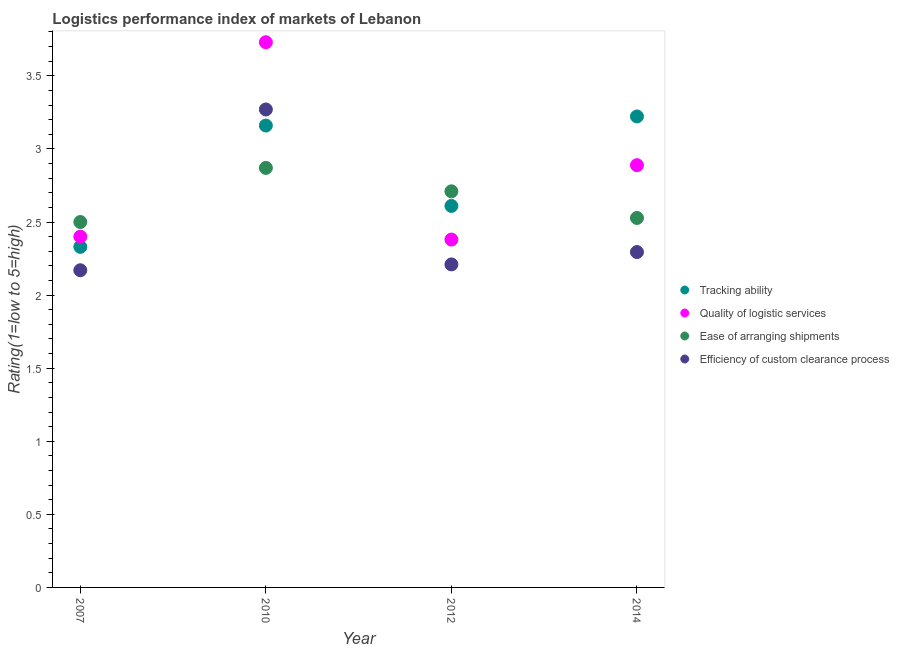Is the number of dotlines equal to the number of legend labels?
Give a very brief answer. Yes. What is the lpi rating of tracking ability in 2012?
Your answer should be very brief. 2.61. Across all years, what is the maximum lpi rating of efficiency of custom clearance process?
Offer a terse response. 3.27. Across all years, what is the minimum lpi rating of quality of logistic services?
Your answer should be very brief. 2.38. In which year was the lpi rating of ease of arranging shipments minimum?
Ensure brevity in your answer.  2007. What is the total lpi rating of tracking ability in the graph?
Your answer should be compact. 11.32. What is the difference between the lpi rating of efficiency of custom clearance process in 2012 and that in 2014?
Keep it short and to the point. -0.08. What is the difference between the lpi rating of efficiency of custom clearance process in 2007 and the lpi rating of tracking ability in 2014?
Ensure brevity in your answer.  -1.05. What is the average lpi rating of tracking ability per year?
Offer a very short reply. 2.83. In the year 2010, what is the difference between the lpi rating of tracking ability and lpi rating of quality of logistic services?
Make the answer very short. -0.57. In how many years, is the lpi rating of efficiency of custom clearance process greater than 2.6?
Ensure brevity in your answer.  1. What is the ratio of the lpi rating of quality of logistic services in 2010 to that in 2014?
Give a very brief answer. 1.29. Is the lpi rating of tracking ability in 2007 less than that in 2010?
Provide a succinct answer. Yes. What is the difference between the highest and the second highest lpi rating of efficiency of custom clearance process?
Offer a terse response. 0.98. What is the difference between the highest and the lowest lpi rating of quality of logistic services?
Your answer should be very brief. 1.35. In how many years, is the lpi rating of tracking ability greater than the average lpi rating of tracking ability taken over all years?
Make the answer very short. 2. Is the sum of the lpi rating of ease of arranging shipments in 2012 and 2014 greater than the maximum lpi rating of tracking ability across all years?
Your answer should be very brief. Yes. Is it the case that in every year, the sum of the lpi rating of tracking ability and lpi rating of quality of logistic services is greater than the lpi rating of ease of arranging shipments?
Your answer should be very brief. Yes. Does the lpi rating of quality of logistic services monotonically increase over the years?
Offer a very short reply. No. Is the lpi rating of tracking ability strictly greater than the lpi rating of quality of logistic services over the years?
Give a very brief answer. No. Is the lpi rating of efficiency of custom clearance process strictly less than the lpi rating of ease of arranging shipments over the years?
Ensure brevity in your answer.  No. How many years are there in the graph?
Provide a succinct answer. 4. What is the difference between two consecutive major ticks on the Y-axis?
Your answer should be very brief. 0.5. Are the values on the major ticks of Y-axis written in scientific E-notation?
Offer a very short reply. No. Does the graph contain any zero values?
Offer a terse response. No. Does the graph contain grids?
Offer a terse response. No. How many legend labels are there?
Your response must be concise. 4. What is the title of the graph?
Provide a short and direct response. Logistics performance index of markets of Lebanon. Does "Source data assessment" appear as one of the legend labels in the graph?
Your answer should be compact. No. What is the label or title of the X-axis?
Offer a very short reply. Year. What is the label or title of the Y-axis?
Keep it short and to the point. Rating(1=low to 5=high). What is the Rating(1=low to 5=high) of Tracking ability in 2007?
Give a very brief answer. 2.33. What is the Rating(1=low to 5=high) in Quality of logistic services in 2007?
Ensure brevity in your answer.  2.4. What is the Rating(1=low to 5=high) of Efficiency of custom clearance process in 2007?
Provide a short and direct response. 2.17. What is the Rating(1=low to 5=high) in Tracking ability in 2010?
Your answer should be very brief. 3.16. What is the Rating(1=low to 5=high) in Quality of logistic services in 2010?
Provide a short and direct response. 3.73. What is the Rating(1=low to 5=high) in Ease of arranging shipments in 2010?
Offer a very short reply. 2.87. What is the Rating(1=low to 5=high) of Efficiency of custom clearance process in 2010?
Give a very brief answer. 3.27. What is the Rating(1=low to 5=high) in Tracking ability in 2012?
Ensure brevity in your answer.  2.61. What is the Rating(1=low to 5=high) of Quality of logistic services in 2012?
Provide a succinct answer. 2.38. What is the Rating(1=low to 5=high) of Ease of arranging shipments in 2012?
Provide a succinct answer. 2.71. What is the Rating(1=low to 5=high) in Efficiency of custom clearance process in 2012?
Your answer should be very brief. 2.21. What is the Rating(1=low to 5=high) of Tracking ability in 2014?
Make the answer very short. 3.22. What is the Rating(1=low to 5=high) of Quality of logistic services in 2014?
Provide a succinct answer. 2.89. What is the Rating(1=low to 5=high) in Ease of arranging shipments in 2014?
Offer a very short reply. 2.53. What is the Rating(1=low to 5=high) in Efficiency of custom clearance process in 2014?
Give a very brief answer. 2.29. Across all years, what is the maximum Rating(1=low to 5=high) in Tracking ability?
Offer a terse response. 3.22. Across all years, what is the maximum Rating(1=low to 5=high) of Quality of logistic services?
Your response must be concise. 3.73. Across all years, what is the maximum Rating(1=low to 5=high) of Ease of arranging shipments?
Your answer should be compact. 2.87. Across all years, what is the maximum Rating(1=low to 5=high) in Efficiency of custom clearance process?
Offer a very short reply. 3.27. Across all years, what is the minimum Rating(1=low to 5=high) of Tracking ability?
Your answer should be compact. 2.33. Across all years, what is the minimum Rating(1=low to 5=high) of Quality of logistic services?
Give a very brief answer. 2.38. Across all years, what is the minimum Rating(1=low to 5=high) of Efficiency of custom clearance process?
Give a very brief answer. 2.17. What is the total Rating(1=low to 5=high) in Tracking ability in the graph?
Make the answer very short. 11.32. What is the total Rating(1=low to 5=high) in Quality of logistic services in the graph?
Offer a very short reply. 11.4. What is the total Rating(1=low to 5=high) of Ease of arranging shipments in the graph?
Your response must be concise. 10.61. What is the total Rating(1=low to 5=high) in Efficiency of custom clearance process in the graph?
Give a very brief answer. 9.94. What is the difference between the Rating(1=low to 5=high) of Tracking ability in 2007 and that in 2010?
Make the answer very short. -0.83. What is the difference between the Rating(1=low to 5=high) of Quality of logistic services in 2007 and that in 2010?
Your answer should be compact. -1.33. What is the difference between the Rating(1=low to 5=high) in Ease of arranging shipments in 2007 and that in 2010?
Your answer should be compact. -0.37. What is the difference between the Rating(1=low to 5=high) of Efficiency of custom clearance process in 2007 and that in 2010?
Offer a very short reply. -1.1. What is the difference between the Rating(1=low to 5=high) in Tracking ability in 2007 and that in 2012?
Give a very brief answer. -0.28. What is the difference between the Rating(1=low to 5=high) in Quality of logistic services in 2007 and that in 2012?
Give a very brief answer. 0.02. What is the difference between the Rating(1=low to 5=high) in Ease of arranging shipments in 2007 and that in 2012?
Your response must be concise. -0.21. What is the difference between the Rating(1=low to 5=high) in Efficiency of custom clearance process in 2007 and that in 2012?
Make the answer very short. -0.04. What is the difference between the Rating(1=low to 5=high) in Tracking ability in 2007 and that in 2014?
Your response must be concise. -0.89. What is the difference between the Rating(1=low to 5=high) of Quality of logistic services in 2007 and that in 2014?
Offer a terse response. -0.49. What is the difference between the Rating(1=low to 5=high) of Ease of arranging shipments in 2007 and that in 2014?
Provide a succinct answer. -0.03. What is the difference between the Rating(1=low to 5=high) in Efficiency of custom clearance process in 2007 and that in 2014?
Keep it short and to the point. -0.12. What is the difference between the Rating(1=low to 5=high) of Tracking ability in 2010 and that in 2012?
Your response must be concise. 0.55. What is the difference between the Rating(1=low to 5=high) of Quality of logistic services in 2010 and that in 2012?
Keep it short and to the point. 1.35. What is the difference between the Rating(1=low to 5=high) in Ease of arranging shipments in 2010 and that in 2012?
Offer a very short reply. 0.16. What is the difference between the Rating(1=low to 5=high) of Efficiency of custom clearance process in 2010 and that in 2012?
Provide a succinct answer. 1.06. What is the difference between the Rating(1=low to 5=high) of Tracking ability in 2010 and that in 2014?
Provide a short and direct response. -0.06. What is the difference between the Rating(1=low to 5=high) in Quality of logistic services in 2010 and that in 2014?
Keep it short and to the point. 0.84. What is the difference between the Rating(1=low to 5=high) in Ease of arranging shipments in 2010 and that in 2014?
Make the answer very short. 0.34. What is the difference between the Rating(1=low to 5=high) in Efficiency of custom clearance process in 2010 and that in 2014?
Your answer should be compact. 0.98. What is the difference between the Rating(1=low to 5=high) of Tracking ability in 2012 and that in 2014?
Offer a terse response. -0.61. What is the difference between the Rating(1=low to 5=high) in Quality of logistic services in 2012 and that in 2014?
Keep it short and to the point. -0.51. What is the difference between the Rating(1=low to 5=high) in Ease of arranging shipments in 2012 and that in 2014?
Give a very brief answer. 0.18. What is the difference between the Rating(1=low to 5=high) of Efficiency of custom clearance process in 2012 and that in 2014?
Your response must be concise. -0.08. What is the difference between the Rating(1=low to 5=high) in Tracking ability in 2007 and the Rating(1=low to 5=high) in Quality of logistic services in 2010?
Provide a short and direct response. -1.4. What is the difference between the Rating(1=low to 5=high) of Tracking ability in 2007 and the Rating(1=low to 5=high) of Ease of arranging shipments in 2010?
Make the answer very short. -0.54. What is the difference between the Rating(1=low to 5=high) of Tracking ability in 2007 and the Rating(1=low to 5=high) of Efficiency of custom clearance process in 2010?
Provide a short and direct response. -0.94. What is the difference between the Rating(1=low to 5=high) in Quality of logistic services in 2007 and the Rating(1=low to 5=high) in Ease of arranging shipments in 2010?
Ensure brevity in your answer.  -0.47. What is the difference between the Rating(1=low to 5=high) of Quality of logistic services in 2007 and the Rating(1=low to 5=high) of Efficiency of custom clearance process in 2010?
Your answer should be very brief. -0.87. What is the difference between the Rating(1=low to 5=high) in Ease of arranging shipments in 2007 and the Rating(1=low to 5=high) in Efficiency of custom clearance process in 2010?
Make the answer very short. -0.77. What is the difference between the Rating(1=low to 5=high) of Tracking ability in 2007 and the Rating(1=low to 5=high) of Ease of arranging shipments in 2012?
Offer a terse response. -0.38. What is the difference between the Rating(1=low to 5=high) of Tracking ability in 2007 and the Rating(1=low to 5=high) of Efficiency of custom clearance process in 2012?
Offer a terse response. 0.12. What is the difference between the Rating(1=low to 5=high) in Quality of logistic services in 2007 and the Rating(1=low to 5=high) in Ease of arranging shipments in 2012?
Make the answer very short. -0.31. What is the difference between the Rating(1=low to 5=high) in Quality of logistic services in 2007 and the Rating(1=low to 5=high) in Efficiency of custom clearance process in 2012?
Offer a very short reply. 0.19. What is the difference between the Rating(1=low to 5=high) in Ease of arranging shipments in 2007 and the Rating(1=low to 5=high) in Efficiency of custom clearance process in 2012?
Offer a terse response. 0.29. What is the difference between the Rating(1=low to 5=high) in Tracking ability in 2007 and the Rating(1=low to 5=high) in Quality of logistic services in 2014?
Ensure brevity in your answer.  -0.56. What is the difference between the Rating(1=low to 5=high) of Tracking ability in 2007 and the Rating(1=low to 5=high) of Ease of arranging shipments in 2014?
Offer a very short reply. -0.2. What is the difference between the Rating(1=low to 5=high) of Tracking ability in 2007 and the Rating(1=low to 5=high) of Efficiency of custom clearance process in 2014?
Keep it short and to the point. 0.04. What is the difference between the Rating(1=low to 5=high) of Quality of logistic services in 2007 and the Rating(1=low to 5=high) of Ease of arranging shipments in 2014?
Give a very brief answer. -0.13. What is the difference between the Rating(1=low to 5=high) in Quality of logistic services in 2007 and the Rating(1=low to 5=high) in Efficiency of custom clearance process in 2014?
Keep it short and to the point. 0.11. What is the difference between the Rating(1=low to 5=high) of Ease of arranging shipments in 2007 and the Rating(1=low to 5=high) of Efficiency of custom clearance process in 2014?
Offer a terse response. 0.21. What is the difference between the Rating(1=low to 5=high) of Tracking ability in 2010 and the Rating(1=low to 5=high) of Quality of logistic services in 2012?
Provide a succinct answer. 0.78. What is the difference between the Rating(1=low to 5=high) of Tracking ability in 2010 and the Rating(1=low to 5=high) of Ease of arranging shipments in 2012?
Keep it short and to the point. 0.45. What is the difference between the Rating(1=low to 5=high) of Quality of logistic services in 2010 and the Rating(1=low to 5=high) of Efficiency of custom clearance process in 2012?
Your answer should be compact. 1.52. What is the difference between the Rating(1=low to 5=high) in Ease of arranging shipments in 2010 and the Rating(1=low to 5=high) in Efficiency of custom clearance process in 2012?
Provide a short and direct response. 0.66. What is the difference between the Rating(1=low to 5=high) in Tracking ability in 2010 and the Rating(1=low to 5=high) in Quality of logistic services in 2014?
Offer a terse response. 0.27. What is the difference between the Rating(1=low to 5=high) of Tracking ability in 2010 and the Rating(1=low to 5=high) of Ease of arranging shipments in 2014?
Your response must be concise. 0.63. What is the difference between the Rating(1=low to 5=high) of Tracking ability in 2010 and the Rating(1=low to 5=high) of Efficiency of custom clearance process in 2014?
Give a very brief answer. 0.87. What is the difference between the Rating(1=low to 5=high) in Quality of logistic services in 2010 and the Rating(1=low to 5=high) in Ease of arranging shipments in 2014?
Offer a very short reply. 1.2. What is the difference between the Rating(1=low to 5=high) in Quality of logistic services in 2010 and the Rating(1=low to 5=high) in Efficiency of custom clearance process in 2014?
Keep it short and to the point. 1.44. What is the difference between the Rating(1=low to 5=high) of Ease of arranging shipments in 2010 and the Rating(1=low to 5=high) of Efficiency of custom clearance process in 2014?
Your answer should be compact. 0.58. What is the difference between the Rating(1=low to 5=high) of Tracking ability in 2012 and the Rating(1=low to 5=high) of Quality of logistic services in 2014?
Offer a terse response. -0.28. What is the difference between the Rating(1=low to 5=high) of Tracking ability in 2012 and the Rating(1=low to 5=high) of Ease of arranging shipments in 2014?
Offer a terse response. 0.08. What is the difference between the Rating(1=low to 5=high) of Tracking ability in 2012 and the Rating(1=low to 5=high) of Efficiency of custom clearance process in 2014?
Provide a short and direct response. 0.32. What is the difference between the Rating(1=low to 5=high) of Quality of logistic services in 2012 and the Rating(1=low to 5=high) of Ease of arranging shipments in 2014?
Give a very brief answer. -0.15. What is the difference between the Rating(1=low to 5=high) in Quality of logistic services in 2012 and the Rating(1=low to 5=high) in Efficiency of custom clearance process in 2014?
Keep it short and to the point. 0.09. What is the difference between the Rating(1=low to 5=high) in Ease of arranging shipments in 2012 and the Rating(1=low to 5=high) in Efficiency of custom clearance process in 2014?
Your answer should be very brief. 0.42. What is the average Rating(1=low to 5=high) of Tracking ability per year?
Make the answer very short. 2.83. What is the average Rating(1=low to 5=high) in Quality of logistic services per year?
Ensure brevity in your answer.  2.85. What is the average Rating(1=low to 5=high) of Ease of arranging shipments per year?
Your answer should be compact. 2.65. What is the average Rating(1=low to 5=high) in Efficiency of custom clearance process per year?
Keep it short and to the point. 2.49. In the year 2007, what is the difference between the Rating(1=low to 5=high) of Tracking ability and Rating(1=low to 5=high) of Quality of logistic services?
Your answer should be very brief. -0.07. In the year 2007, what is the difference between the Rating(1=low to 5=high) in Tracking ability and Rating(1=low to 5=high) in Ease of arranging shipments?
Your answer should be very brief. -0.17. In the year 2007, what is the difference between the Rating(1=low to 5=high) of Tracking ability and Rating(1=low to 5=high) of Efficiency of custom clearance process?
Keep it short and to the point. 0.16. In the year 2007, what is the difference between the Rating(1=low to 5=high) in Quality of logistic services and Rating(1=low to 5=high) in Efficiency of custom clearance process?
Your answer should be very brief. 0.23. In the year 2007, what is the difference between the Rating(1=low to 5=high) in Ease of arranging shipments and Rating(1=low to 5=high) in Efficiency of custom clearance process?
Keep it short and to the point. 0.33. In the year 2010, what is the difference between the Rating(1=low to 5=high) in Tracking ability and Rating(1=low to 5=high) in Quality of logistic services?
Offer a very short reply. -0.57. In the year 2010, what is the difference between the Rating(1=low to 5=high) of Tracking ability and Rating(1=low to 5=high) of Ease of arranging shipments?
Provide a short and direct response. 0.29. In the year 2010, what is the difference between the Rating(1=low to 5=high) in Tracking ability and Rating(1=low to 5=high) in Efficiency of custom clearance process?
Make the answer very short. -0.11. In the year 2010, what is the difference between the Rating(1=low to 5=high) in Quality of logistic services and Rating(1=low to 5=high) in Ease of arranging shipments?
Give a very brief answer. 0.86. In the year 2010, what is the difference between the Rating(1=low to 5=high) of Quality of logistic services and Rating(1=low to 5=high) of Efficiency of custom clearance process?
Your answer should be very brief. 0.46. In the year 2012, what is the difference between the Rating(1=low to 5=high) in Tracking ability and Rating(1=low to 5=high) in Quality of logistic services?
Offer a very short reply. 0.23. In the year 2012, what is the difference between the Rating(1=low to 5=high) in Tracking ability and Rating(1=low to 5=high) in Ease of arranging shipments?
Your response must be concise. -0.1. In the year 2012, what is the difference between the Rating(1=low to 5=high) in Tracking ability and Rating(1=low to 5=high) in Efficiency of custom clearance process?
Offer a terse response. 0.4. In the year 2012, what is the difference between the Rating(1=low to 5=high) of Quality of logistic services and Rating(1=low to 5=high) of Ease of arranging shipments?
Your answer should be compact. -0.33. In the year 2012, what is the difference between the Rating(1=low to 5=high) of Quality of logistic services and Rating(1=low to 5=high) of Efficiency of custom clearance process?
Your answer should be very brief. 0.17. In the year 2014, what is the difference between the Rating(1=low to 5=high) of Tracking ability and Rating(1=low to 5=high) of Ease of arranging shipments?
Make the answer very short. 0.69. In the year 2014, what is the difference between the Rating(1=low to 5=high) in Tracking ability and Rating(1=low to 5=high) in Efficiency of custom clearance process?
Give a very brief answer. 0.93. In the year 2014, what is the difference between the Rating(1=low to 5=high) of Quality of logistic services and Rating(1=low to 5=high) of Ease of arranging shipments?
Keep it short and to the point. 0.36. In the year 2014, what is the difference between the Rating(1=low to 5=high) of Quality of logistic services and Rating(1=low to 5=high) of Efficiency of custom clearance process?
Offer a terse response. 0.59. In the year 2014, what is the difference between the Rating(1=low to 5=high) in Ease of arranging shipments and Rating(1=low to 5=high) in Efficiency of custom clearance process?
Keep it short and to the point. 0.23. What is the ratio of the Rating(1=low to 5=high) of Tracking ability in 2007 to that in 2010?
Your answer should be compact. 0.74. What is the ratio of the Rating(1=low to 5=high) in Quality of logistic services in 2007 to that in 2010?
Give a very brief answer. 0.64. What is the ratio of the Rating(1=low to 5=high) of Ease of arranging shipments in 2007 to that in 2010?
Provide a succinct answer. 0.87. What is the ratio of the Rating(1=low to 5=high) in Efficiency of custom clearance process in 2007 to that in 2010?
Your answer should be compact. 0.66. What is the ratio of the Rating(1=low to 5=high) in Tracking ability in 2007 to that in 2012?
Offer a terse response. 0.89. What is the ratio of the Rating(1=low to 5=high) of Quality of logistic services in 2007 to that in 2012?
Keep it short and to the point. 1.01. What is the ratio of the Rating(1=low to 5=high) in Ease of arranging shipments in 2007 to that in 2012?
Your answer should be compact. 0.92. What is the ratio of the Rating(1=low to 5=high) of Efficiency of custom clearance process in 2007 to that in 2012?
Provide a short and direct response. 0.98. What is the ratio of the Rating(1=low to 5=high) in Tracking ability in 2007 to that in 2014?
Your answer should be compact. 0.72. What is the ratio of the Rating(1=low to 5=high) of Quality of logistic services in 2007 to that in 2014?
Keep it short and to the point. 0.83. What is the ratio of the Rating(1=low to 5=high) of Ease of arranging shipments in 2007 to that in 2014?
Make the answer very short. 0.99. What is the ratio of the Rating(1=low to 5=high) in Efficiency of custom clearance process in 2007 to that in 2014?
Your answer should be compact. 0.95. What is the ratio of the Rating(1=low to 5=high) of Tracking ability in 2010 to that in 2012?
Ensure brevity in your answer.  1.21. What is the ratio of the Rating(1=low to 5=high) in Quality of logistic services in 2010 to that in 2012?
Provide a succinct answer. 1.57. What is the ratio of the Rating(1=low to 5=high) of Ease of arranging shipments in 2010 to that in 2012?
Keep it short and to the point. 1.06. What is the ratio of the Rating(1=low to 5=high) of Efficiency of custom clearance process in 2010 to that in 2012?
Ensure brevity in your answer.  1.48. What is the ratio of the Rating(1=low to 5=high) of Tracking ability in 2010 to that in 2014?
Provide a succinct answer. 0.98. What is the ratio of the Rating(1=low to 5=high) of Quality of logistic services in 2010 to that in 2014?
Your response must be concise. 1.29. What is the ratio of the Rating(1=low to 5=high) in Ease of arranging shipments in 2010 to that in 2014?
Provide a succinct answer. 1.14. What is the ratio of the Rating(1=low to 5=high) in Efficiency of custom clearance process in 2010 to that in 2014?
Ensure brevity in your answer.  1.43. What is the ratio of the Rating(1=low to 5=high) in Tracking ability in 2012 to that in 2014?
Keep it short and to the point. 0.81. What is the ratio of the Rating(1=low to 5=high) of Quality of logistic services in 2012 to that in 2014?
Provide a short and direct response. 0.82. What is the ratio of the Rating(1=low to 5=high) in Ease of arranging shipments in 2012 to that in 2014?
Ensure brevity in your answer.  1.07. What is the ratio of the Rating(1=low to 5=high) of Efficiency of custom clearance process in 2012 to that in 2014?
Provide a short and direct response. 0.96. What is the difference between the highest and the second highest Rating(1=low to 5=high) in Tracking ability?
Ensure brevity in your answer.  0.06. What is the difference between the highest and the second highest Rating(1=low to 5=high) of Quality of logistic services?
Keep it short and to the point. 0.84. What is the difference between the highest and the second highest Rating(1=low to 5=high) in Ease of arranging shipments?
Provide a succinct answer. 0.16. What is the difference between the highest and the second highest Rating(1=low to 5=high) in Efficiency of custom clearance process?
Provide a succinct answer. 0.98. What is the difference between the highest and the lowest Rating(1=low to 5=high) of Tracking ability?
Your answer should be compact. 0.89. What is the difference between the highest and the lowest Rating(1=low to 5=high) in Quality of logistic services?
Provide a short and direct response. 1.35. What is the difference between the highest and the lowest Rating(1=low to 5=high) in Ease of arranging shipments?
Your response must be concise. 0.37. What is the difference between the highest and the lowest Rating(1=low to 5=high) in Efficiency of custom clearance process?
Your response must be concise. 1.1. 